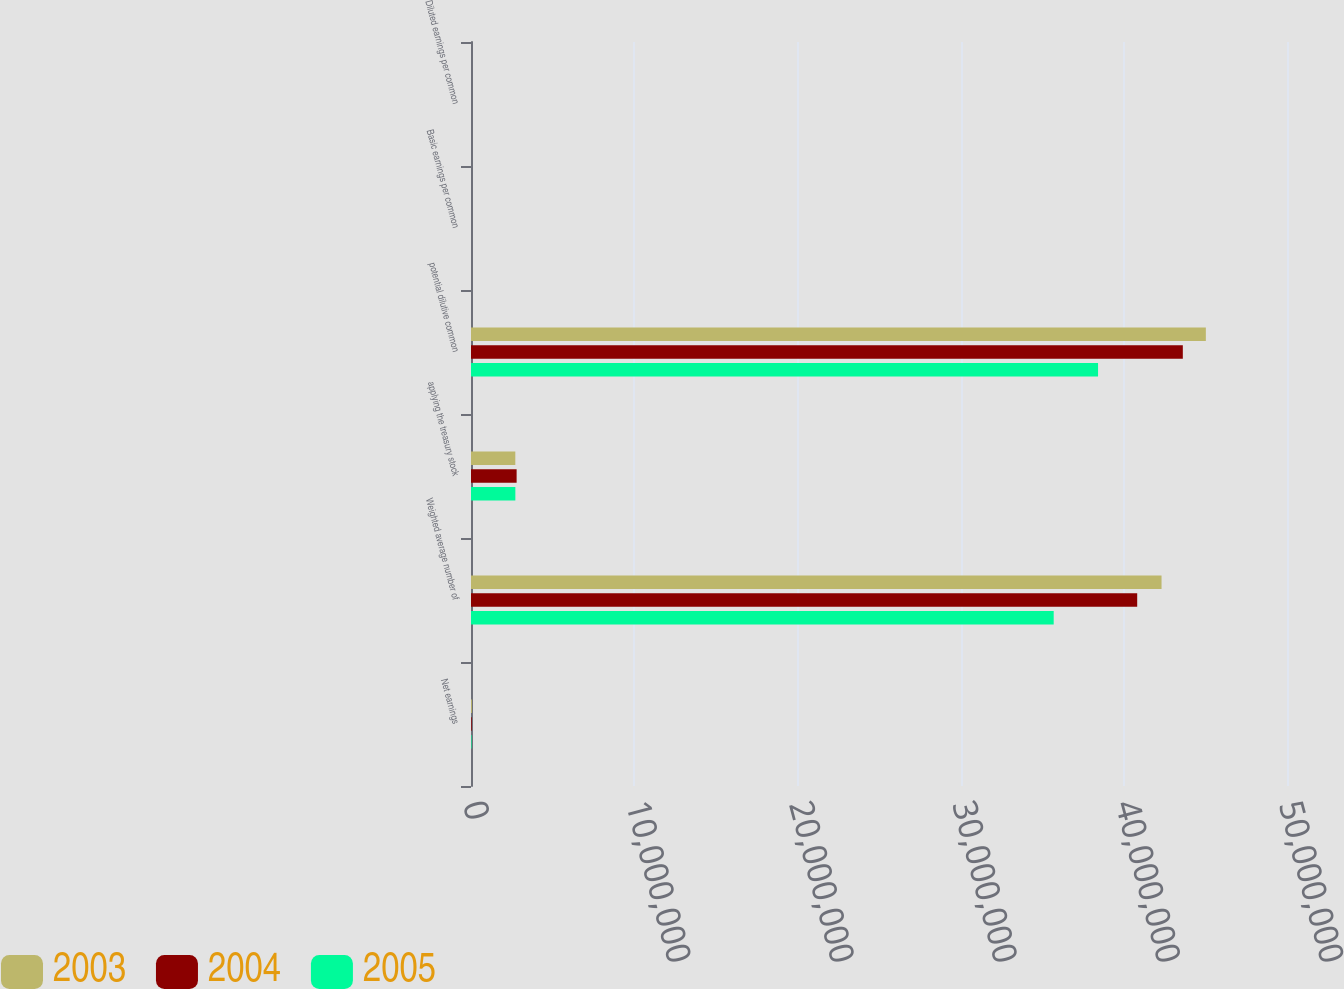<chart> <loc_0><loc_0><loc_500><loc_500><stacked_bar_chart><ecel><fcel>Net earnings<fcel>Weighted average number of<fcel>applying the treasury stock<fcel>potential dilutive common<fcel>Basic earnings per common<fcel>Diluted earnings per common<nl><fcel>2003<fcel>55632<fcel>4.23125e+07<fcel>2.71511e+06<fcel>4.50276e+07<fcel>1.31<fcel>1.24<nl><fcel>2004<fcel>44312<fcel>4.08209e+07<fcel>2.79554e+06<fcel>4.36164e+07<fcel>1.09<fcel>1.02<nl><fcel>2005<fcel>33270<fcel>3.57044e+07<fcel>2.71773e+06<fcel>3.84222e+07<fcel>0.93<fcel>0.87<nl></chart> 